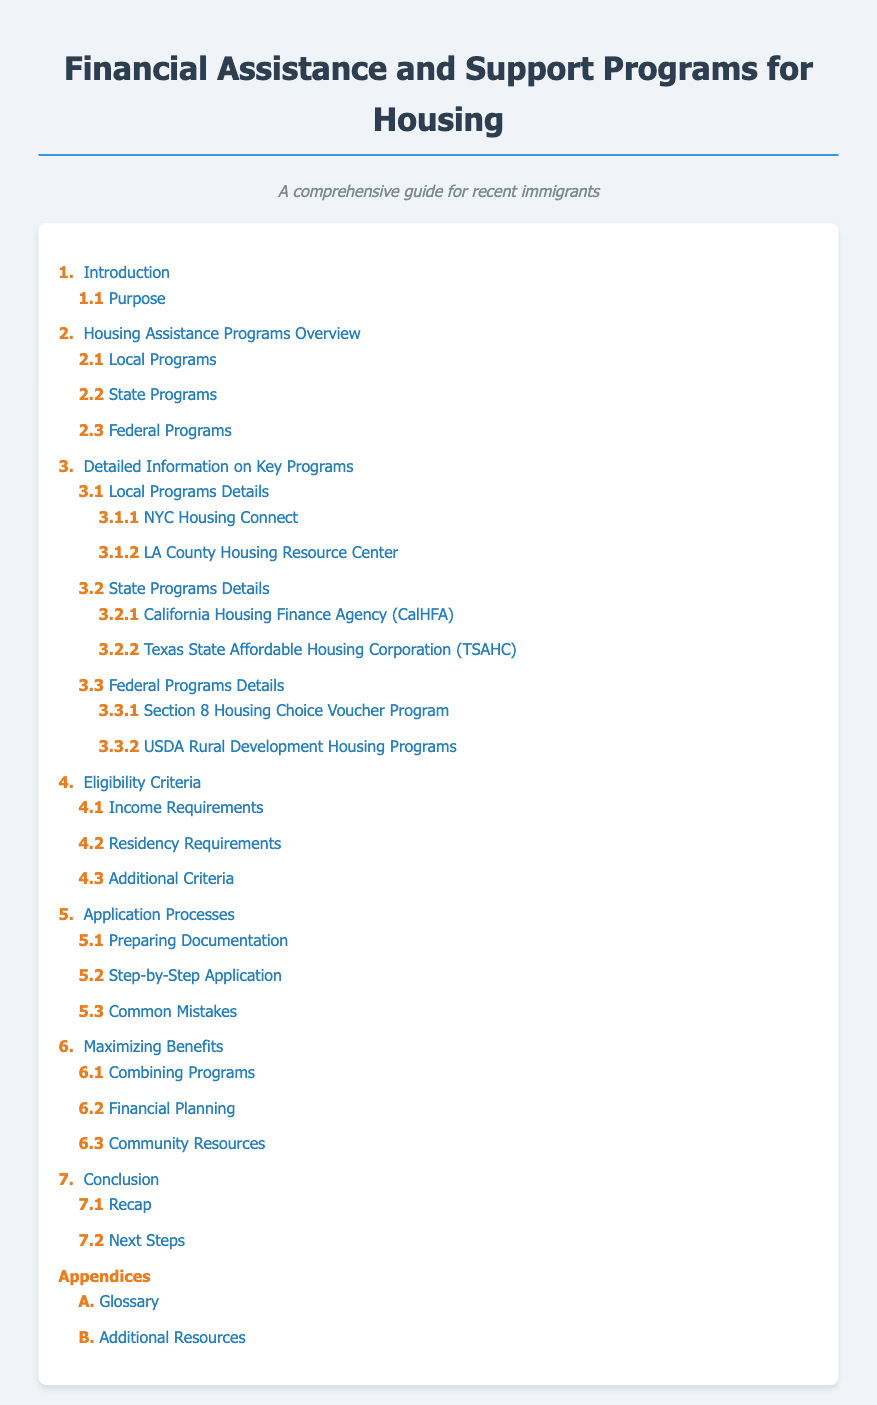What is the title of the document? The title is the main heading of the document which is provided at the top.
Answer: Financial Assistance and Support Programs for Housing What section discusses Local Programs? This section can be found under the Housing Assistance Programs Overview heading, detailing local initiatives.
Answer: 2.1 Local Programs Which program is detailed under NYC Housing Connect? This specific program information is found in the Detailed Information section regarding local programs.
Answer: 3.1.1 NYC Housing Connect How many sub-sections are under Eligibility Criteria? The sub-sections provide detailed criteria essential to qualify for assistance programs.
Answer: 3 What is a key tip for maximizing benefits mentioned in the document? Maximizing benefits includes strategies to effectively combine multiple programs available for assistance.
Answer: Combining Programs What additional resources section can be found in the appendices? This section provides further help and guidance resources for individuals seeking assistance.
Answer: B. Additional Resources What is the purpose of this document? The purpose can be found in the Introduction section which outlines the goal of the document.
Answer: Purpose Which program is associated with USDA? This program information is found under the Federal Programs Details section of the document.
Answer: 3.3.2 USDA Rural Development Housing Programs What is a common mistake to avoid in the application process? Identifying common pitfalls can greatly enhance the chances of application approval.
Answer: Common Mistakes 